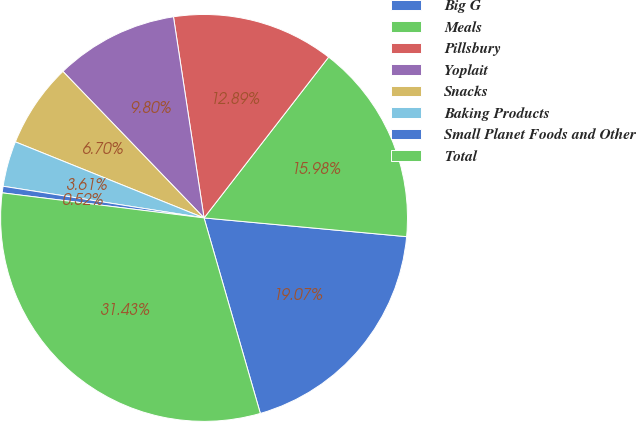Convert chart to OTSL. <chart><loc_0><loc_0><loc_500><loc_500><pie_chart><fcel>Big G<fcel>Meals<fcel>Pillsbury<fcel>Yoplait<fcel>Snacks<fcel>Baking Products<fcel>Small Planet Foods and Other<fcel>Total<nl><fcel>19.07%<fcel>15.98%<fcel>12.89%<fcel>9.8%<fcel>6.7%<fcel>3.61%<fcel>0.52%<fcel>31.43%<nl></chart> 